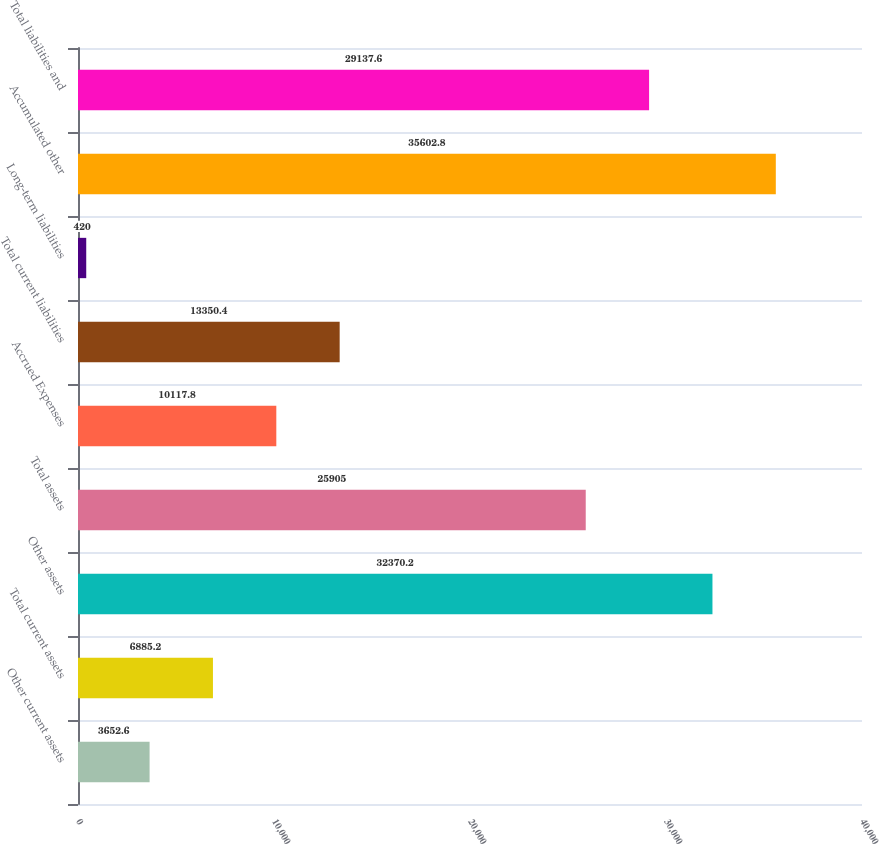Convert chart. <chart><loc_0><loc_0><loc_500><loc_500><bar_chart><fcel>Other current assets<fcel>Total current assets<fcel>Other assets<fcel>Total assets<fcel>Accrued Expenses<fcel>Total current liabilities<fcel>Long-term liabilities<fcel>Accumulated other<fcel>Total liabilities and<nl><fcel>3652.6<fcel>6885.2<fcel>32370.2<fcel>25905<fcel>10117.8<fcel>13350.4<fcel>420<fcel>35602.8<fcel>29137.6<nl></chart> 